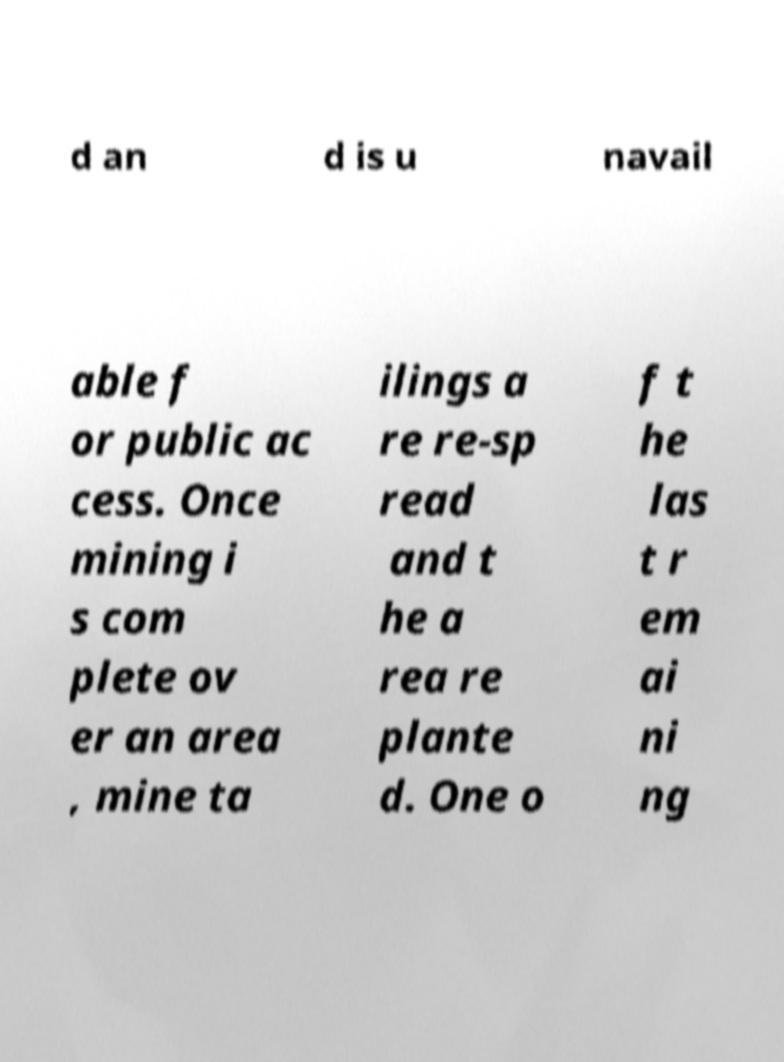I need the written content from this picture converted into text. Can you do that? d an d is u navail able f or public ac cess. Once mining i s com plete ov er an area , mine ta ilings a re re-sp read and t he a rea re plante d. One o f t he las t r em ai ni ng 